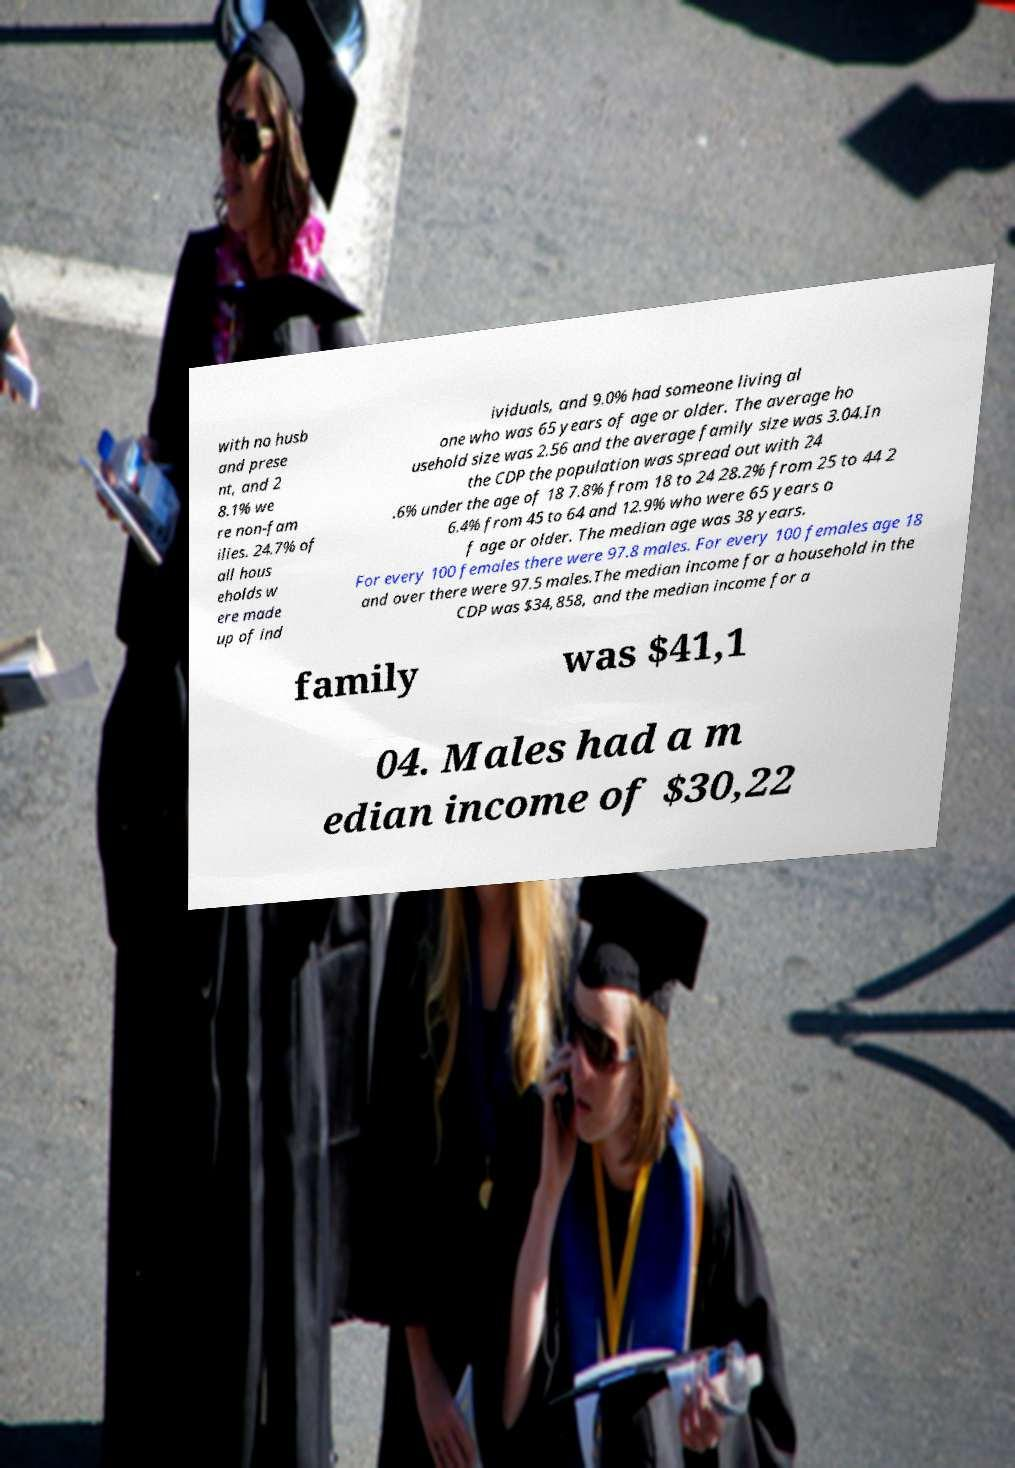Can you accurately transcribe the text from the provided image for me? with no husb and prese nt, and 2 8.1% we re non-fam ilies. 24.7% of all hous eholds w ere made up of ind ividuals, and 9.0% had someone living al one who was 65 years of age or older. The average ho usehold size was 2.56 and the average family size was 3.04.In the CDP the population was spread out with 24 .6% under the age of 18 7.8% from 18 to 24 28.2% from 25 to 44 2 6.4% from 45 to 64 and 12.9% who were 65 years o f age or older. The median age was 38 years. For every 100 females there were 97.8 males. For every 100 females age 18 and over there were 97.5 males.The median income for a household in the CDP was $34,858, and the median income for a family was $41,1 04. Males had a m edian income of $30,22 